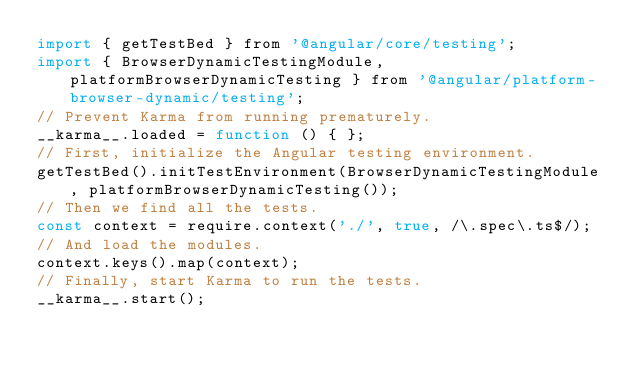Convert code to text. <code><loc_0><loc_0><loc_500><loc_500><_JavaScript_>import { getTestBed } from '@angular/core/testing';
import { BrowserDynamicTestingModule, platformBrowserDynamicTesting } from '@angular/platform-browser-dynamic/testing';
// Prevent Karma from running prematurely.
__karma__.loaded = function () { };
// First, initialize the Angular testing environment.
getTestBed().initTestEnvironment(BrowserDynamicTestingModule, platformBrowserDynamicTesting());
// Then we find all the tests.
const context = require.context('./', true, /\.spec\.ts$/);
// And load the modules.
context.keys().map(context);
// Finally, start Karma to run the tests.
__karma__.start();
</code> 